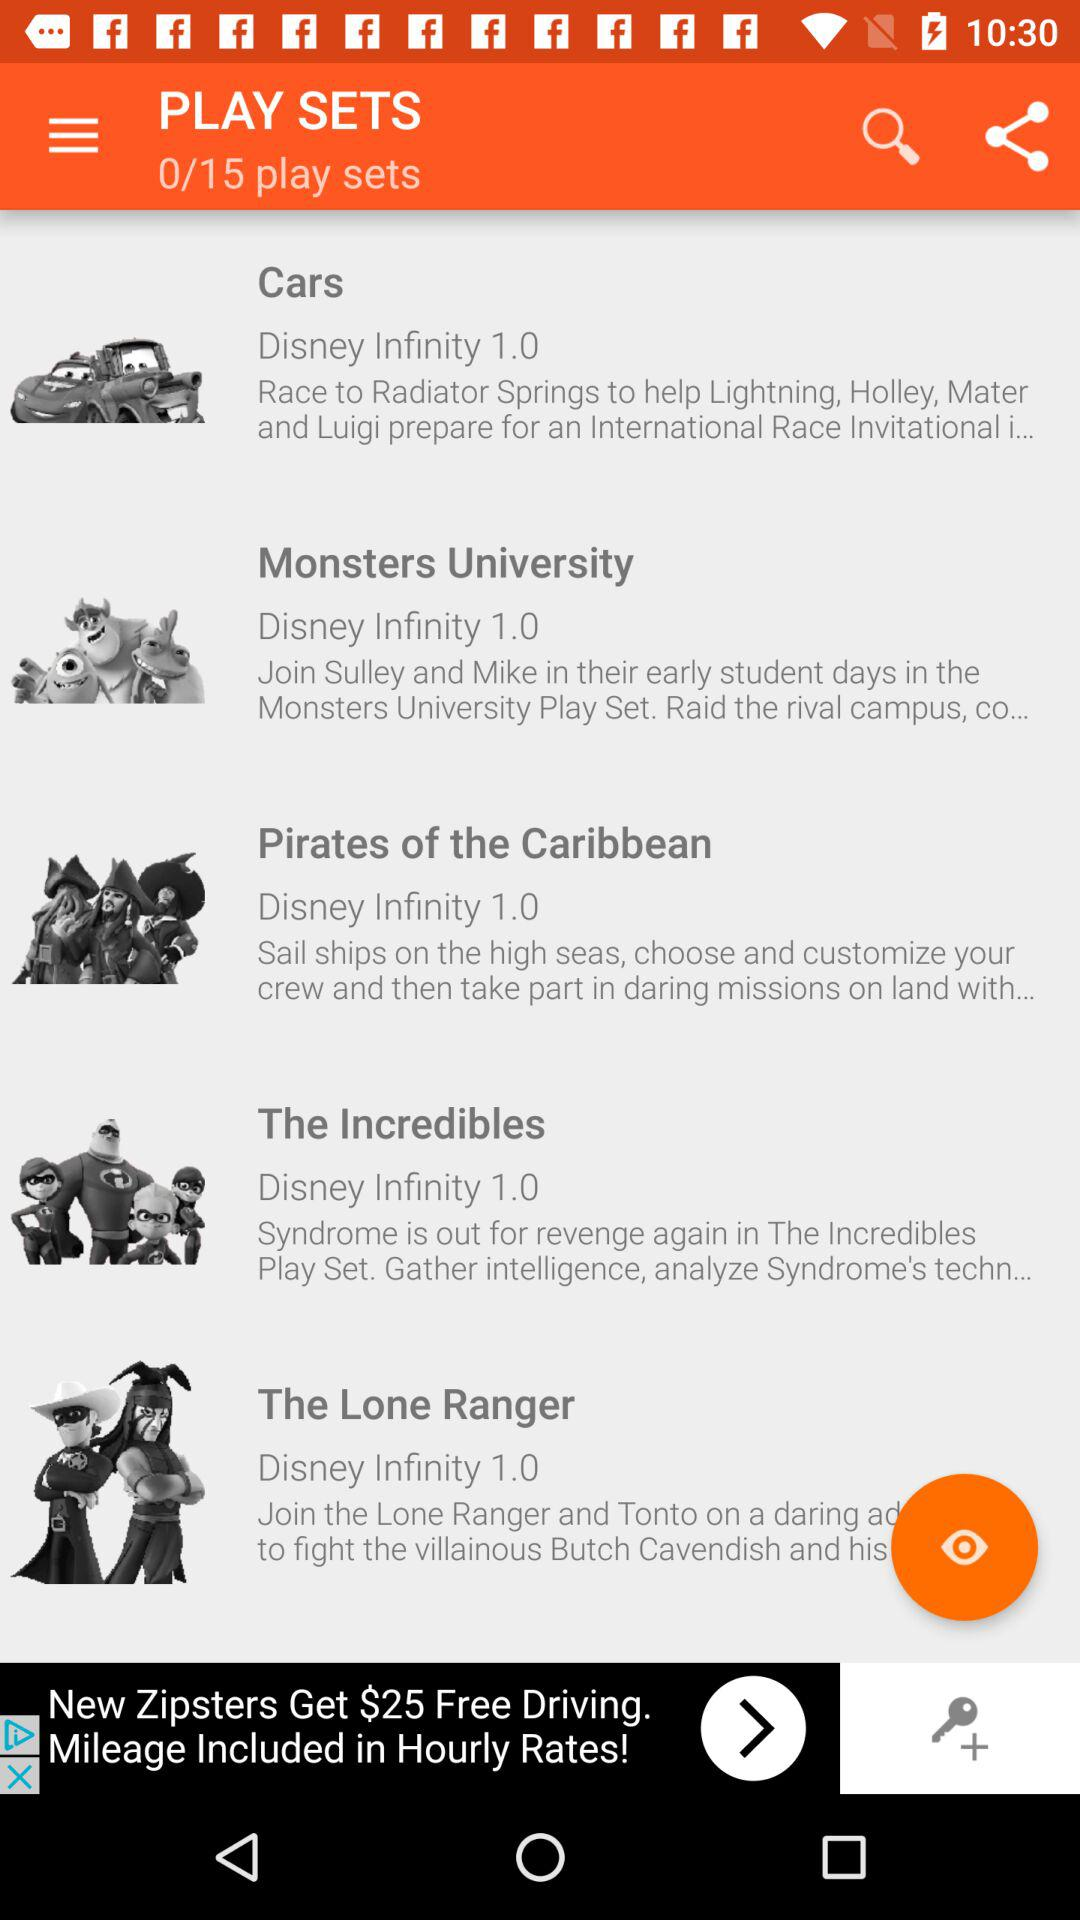How many play sets in total are there? There are 15 play sets in total. 